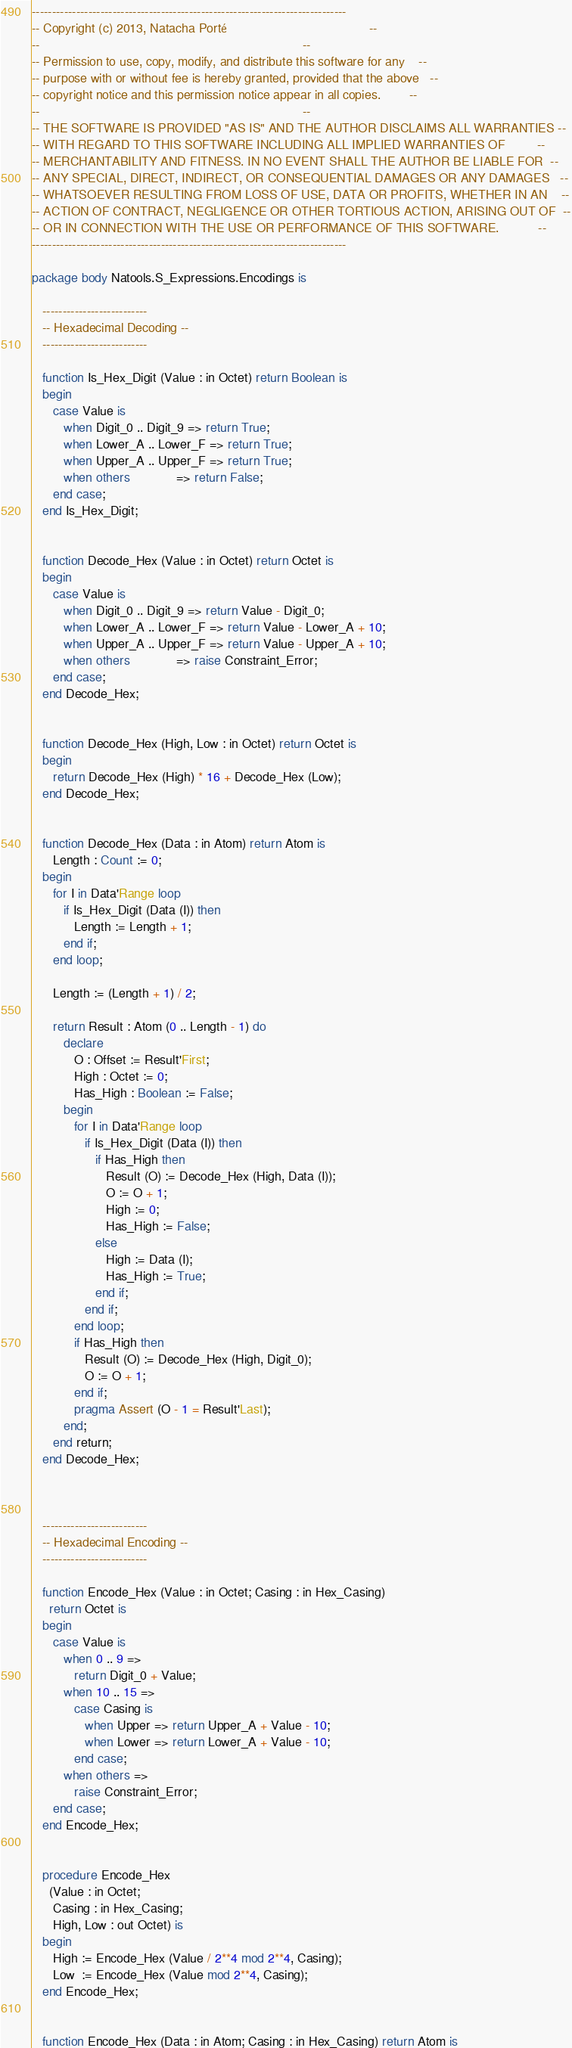Convert code to text. <code><loc_0><loc_0><loc_500><loc_500><_Ada_>------------------------------------------------------------------------------
-- Copyright (c) 2013, Natacha Porté                                        --
--                                                                          --
-- Permission to use, copy, modify, and distribute this software for any    --
-- purpose with or without fee is hereby granted, provided that the above   --
-- copyright notice and this permission notice appear in all copies.        --
--                                                                          --
-- THE SOFTWARE IS PROVIDED "AS IS" AND THE AUTHOR DISCLAIMS ALL WARRANTIES --
-- WITH REGARD TO THIS SOFTWARE INCLUDING ALL IMPLIED WARRANTIES OF         --
-- MERCHANTABILITY AND FITNESS. IN NO EVENT SHALL THE AUTHOR BE LIABLE FOR  --
-- ANY SPECIAL, DIRECT, INDIRECT, OR CONSEQUENTIAL DAMAGES OR ANY DAMAGES   --
-- WHATSOEVER RESULTING FROM LOSS OF USE, DATA OR PROFITS, WHETHER IN AN    --
-- ACTION OF CONTRACT, NEGLIGENCE OR OTHER TORTIOUS ACTION, ARISING OUT OF  --
-- OR IN CONNECTION WITH THE USE OR PERFORMANCE OF THIS SOFTWARE.           --
------------------------------------------------------------------------------

package body Natools.S_Expressions.Encodings is

   --------------------------
   -- Hexadecimal Decoding --
   --------------------------

   function Is_Hex_Digit (Value : in Octet) return Boolean is
   begin
      case Value is
         when Digit_0 .. Digit_9 => return True;
         when Lower_A .. Lower_F => return True;
         when Upper_A .. Upper_F => return True;
         when others             => return False;
      end case;
   end Is_Hex_Digit;


   function Decode_Hex (Value : in Octet) return Octet is
   begin
      case Value is
         when Digit_0 .. Digit_9 => return Value - Digit_0;
         when Lower_A .. Lower_F => return Value - Lower_A + 10;
         when Upper_A .. Upper_F => return Value - Upper_A + 10;
         when others             => raise Constraint_Error;
      end case;
   end Decode_Hex;


   function Decode_Hex (High, Low : in Octet) return Octet is
   begin
      return Decode_Hex (High) * 16 + Decode_Hex (Low);
   end Decode_Hex;


   function Decode_Hex (Data : in Atom) return Atom is
      Length : Count := 0;
   begin
      for I in Data'Range loop
         if Is_Hex_Digit (Data (I)) then
            Length := Length + 1;
         end if;
      end loop;

      Length := (Length + 1) / 2;

      return Result : Atom (0 .. Length - 1) do
         declare
            O : Offset := Result'First;
            High : Octet := 0;
            Has_High : Boolean := False;
         begin
            for I in Data'Range loop
               if Is_Hex_Digit (Data (I)) then
                  if Has_High then
                     Result (O) := Decode_Hex (High, Data (I));
                     O := O + 1;
                     High := 0;
                     Has_High := False;
                  else
                     High := Data (I);
                     Has_High := True;
                  end if;
               end if;
            end loop;
            if Has_High then
               Result (O) := Decode_Hex (High, Digit_0);
               O := O + 1;
            end if;
            pragma Assert (O - 1 = Result'Last);
         end;
      end return;
   end Decode_Hex;



   --------------------------
   -- Hexadecimal Encoding --
   --------------------------

   function Encode_Hex (Value : in Octet; Casing : in Hex_Casing)
     return Octet is
   begin
      case Value is
         when 0 .. 9 =>
            return Digit_0 + Value;
         when 10 .. 15 =>
            case Casing is
               when Upper => return Upper_A + Value - 10;
               when Lower => return Lower_A + Value - 10;
            end case;
         when others =>
            raise Constraint_Error;
      end case;
   end Encode_Hex;


   procedure Encode_Hex
     (Value : in Octet;
      Casing : in Hex_Casing;
      High, Low : out Octet) is
   begin
      High := Encode_Hex (Value / 2**4 mod 2**4, Casing);
      Low  := Encode_Hex (Value mod 2**4, Casing);
   end Encode_Hex;


   function Encode_Hex (Data : in Atom; Casing : in Hex_Casing) return Atom is</code> 